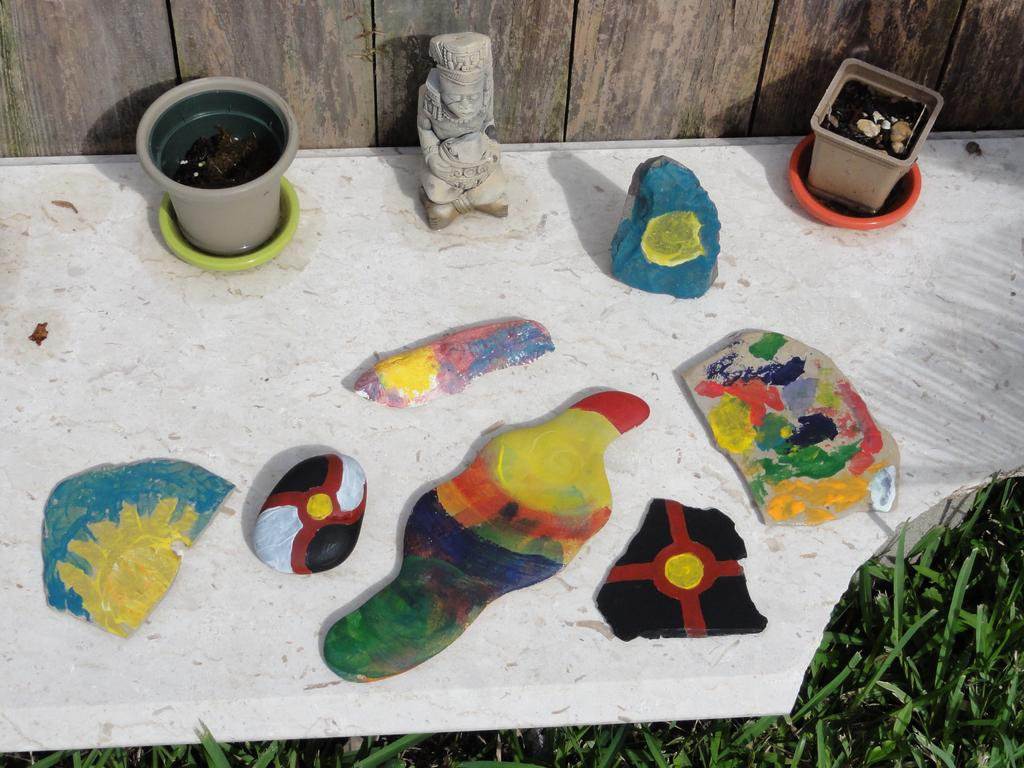What type of furniture is present in the image? There is a bench in the image. What is placed on the bench? The bench contains two plant pots filled with water. What artistic element can be seen in the image? There is a sculpture in the image. What other items are visible in the image? There are some objects in the image. What type of natural environment is visible in the image? There is grass visible in the bottom right of the image. What type of prose is being recited by the lead character in the image? There is no lead character or any prose being recited in the image; it features a bench, plant pots, a sculpture, objects, and grass. 